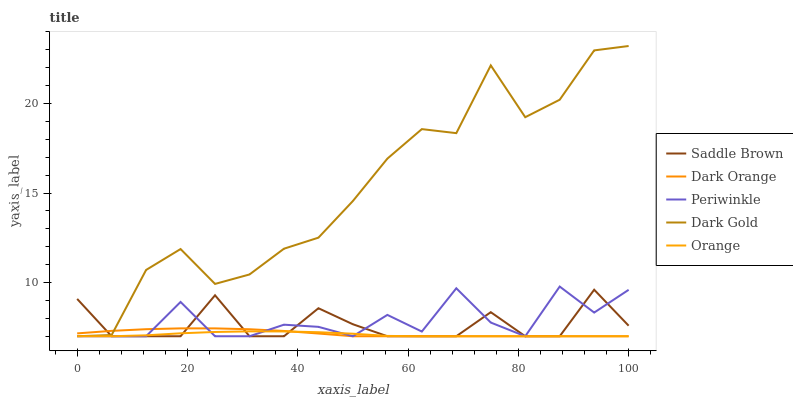Does Orange have the minimum area under the curve?
Answer yes or no. Yes. Does Dark Gold have the maximum area under the curve?
Answer yes or no. Yes. Does Dark Orange have the minimum area under the curve?
Answer yes or no. No. Does Dark Orange have the maximum area under the curve?
Answer yes or no. No. Is Dark Orange the smoothest?
Answer yes or no. Yes. Is Dark Gold the roughest?
Answer yes or no. Yes. Is Periwinkle the smoothest?
Answer yes or no. No. Is Periwinkle the roughest?
Answer yes or no. No. Does Orange have the lowest value?
Answer yes or no. Yes. Does Dark Gold have the highest value?
Answer yes or no. Yes. Does Dark Orange have the highest value?
Answer yes or no. No. Does Dark Orange intersect Saddle Brown?
Answer yes or no. Yes. Is Dark Orange less than Saddle Brown?
Answer yes or no. No. Is Dark Orange greater than Saddle Brown?
Answer yes or no. No. 